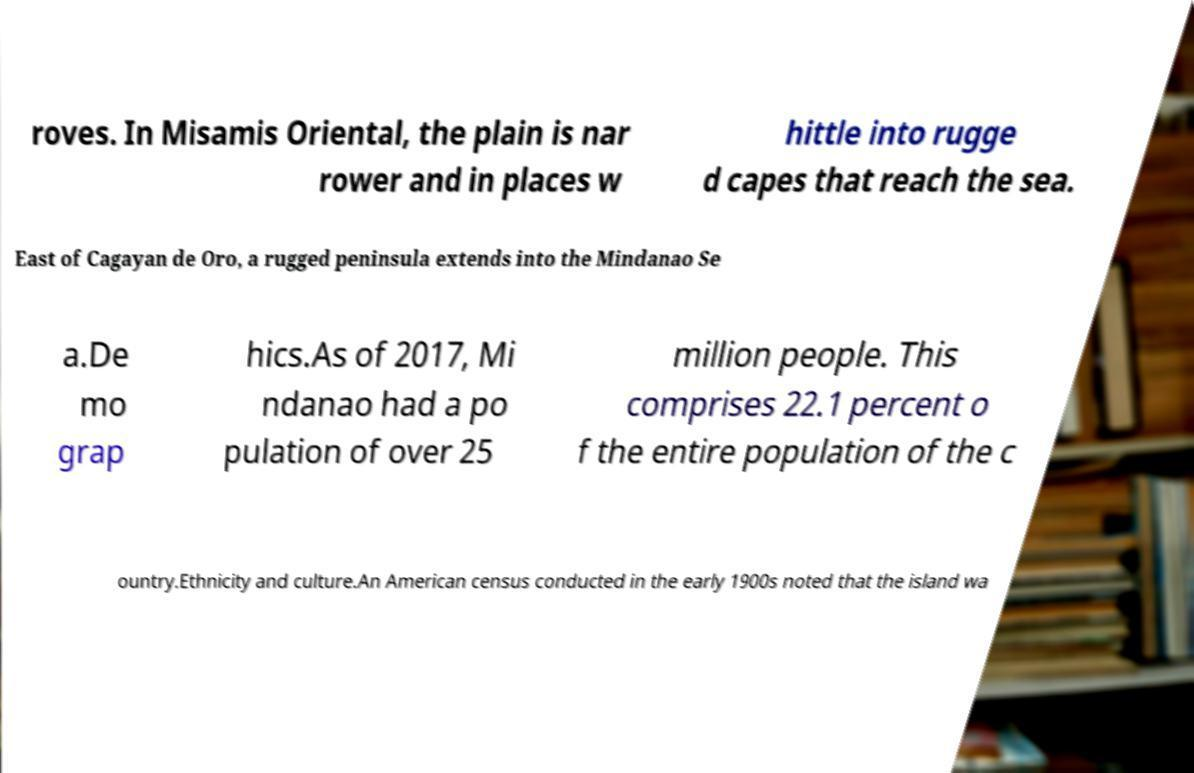Could you assist in decoding the text presented in this image and type it out clearly? roves. In Misamis Oriental, the plain is nar rower and in places w hittle into rugge d capes that reach the sea. East of Cagayan de Oro, a rugged peninsula extends into the Mindanao Se a.De mo grap hics.As of 2017, Mi ndanao had a po pulation of over 25 million people. This comprises 22.1 percent o f the entire population of the c ountry.Ethnicity and culture.An American census conducted in the early 1900s noted that the island wa 